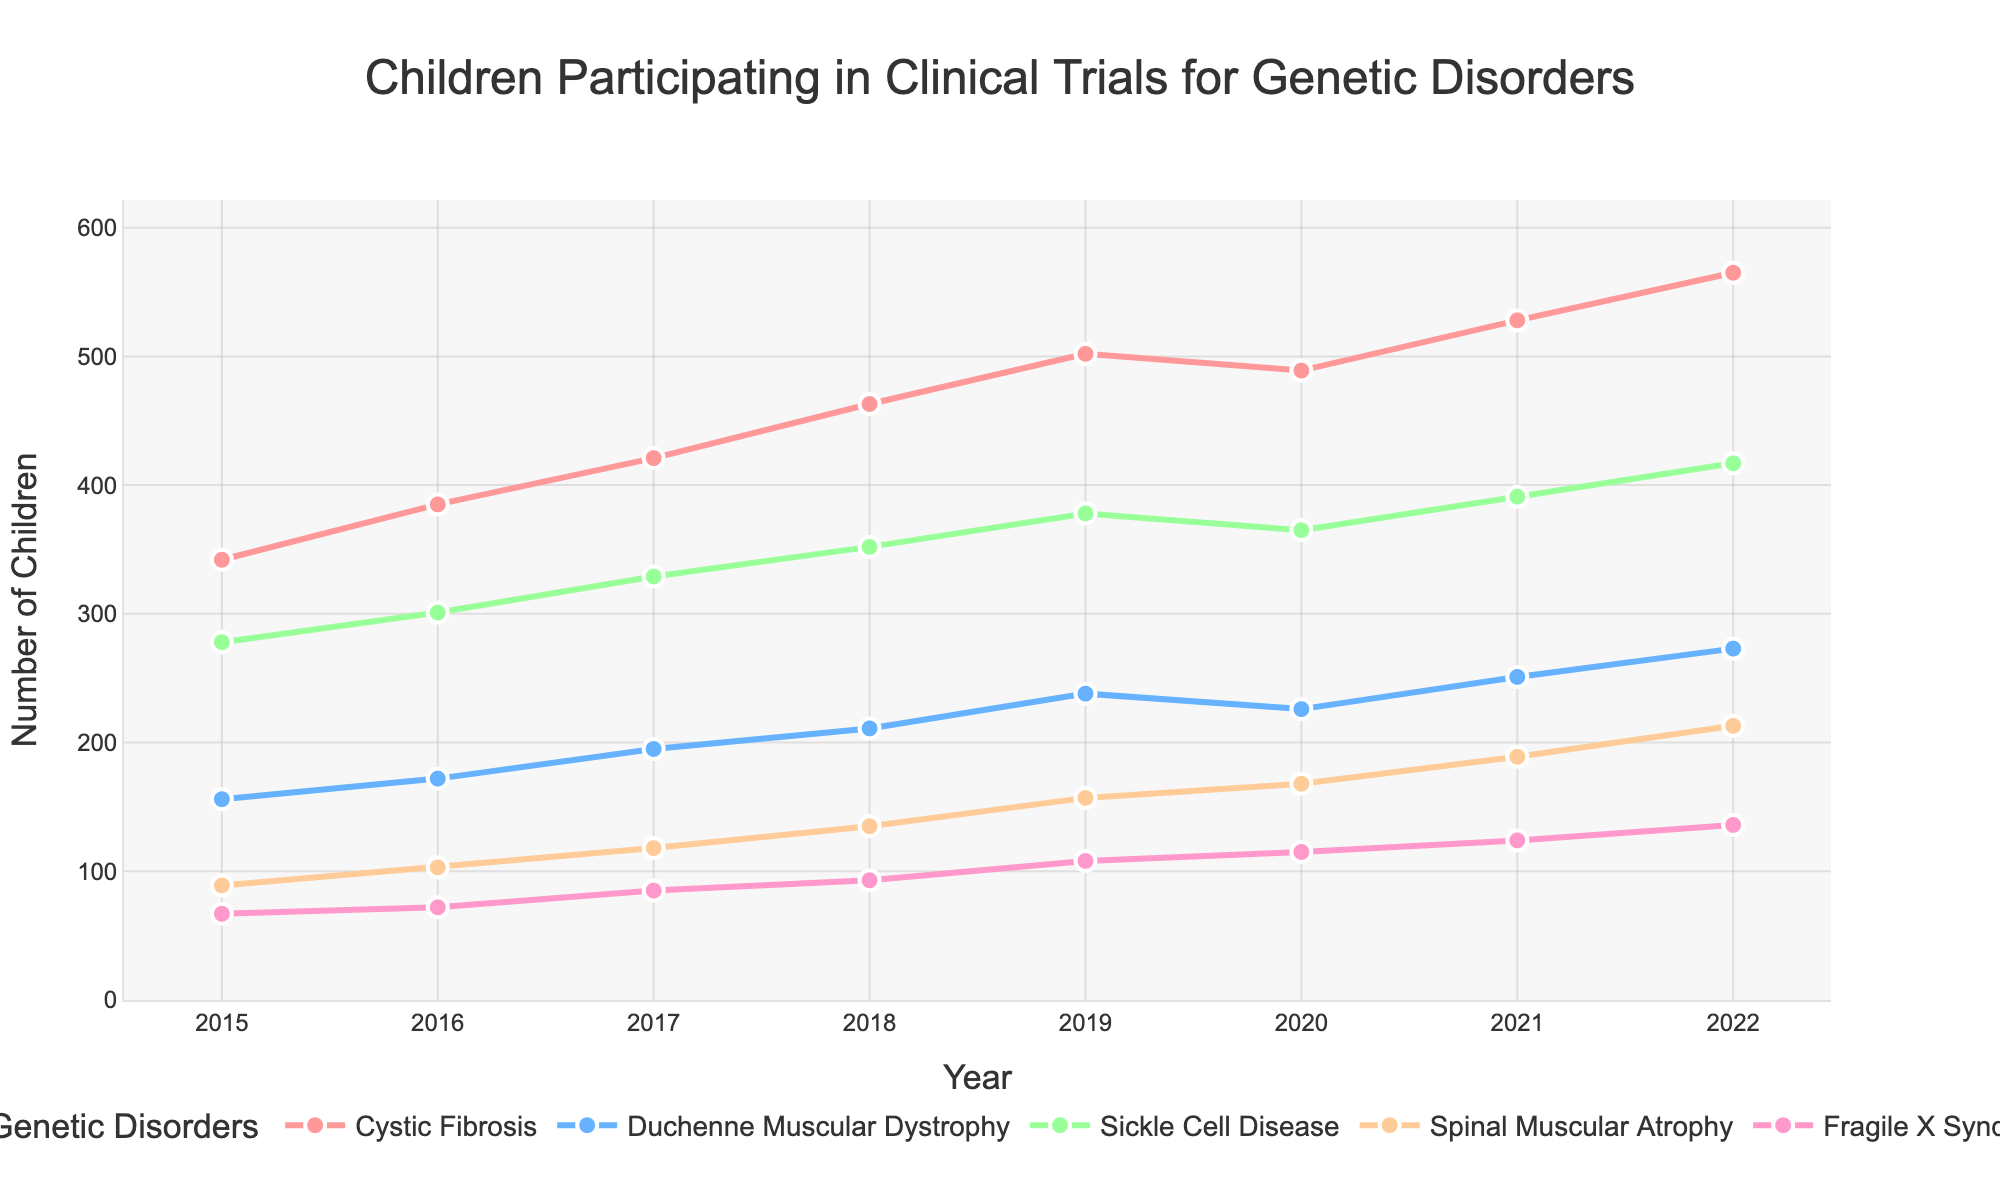Which genetic disorder had the highest number of children participating in clinical trials in 2022? Look at the highest point of each line in 2022. The highest value in 2022 is for Cystic Fibrosis.
Answer: Cystic Fibrosis Which year had the highest number of children participating in clinical trials for Sickle Cell Disease? Check the Sickle Cell Disease line and identify the year with the highest point. The highest point on the line is in 2022.
Answer: 2022 How did the number of children participating in Duchenne Muscular Dystrophy trials change from 2015 to 2022? Look at the figures in 2015 and 2022 for Duchenne Muscular Dystrophy. Subtract the 2015 value from the 2022 value. The participation increased from 156 to 273.
Answer: Increased Which condition shows a decrease in the number of participants from 2019 to 2020? Compare data points in 2019 and 2020 for all lines. Cystic Fibrosis shows a decrease from 502 in 2019 to 489 in 2020.
Answer: Cystic Fibrosis What is the average number of children participating in clinical trials for Spinal Muscular Atrophy from 2015 to 2022? Sum the values for Spinal Muscular Atrophy from 2015 to 2022, then divide by the number of years. (89+103+118+135+157+168+189+213) / 8 = 147.75.
Answer: 147.75 Between which years did Fragile X Syndrome see the largest increase in participants? Check the Fragile X Syndrome line, and find the year-to-year differences. The largest increase is from 2015 to 2016 (67 to 72).
Answer: 2015 to 2016 Which disorder had the smallest number of children participating in trials in 2015? Look at the 2015 data points for each line and find the smallest value. Fragile X Syndrome had the smallest number with 67 participants.
Answer: Fragile X Syndrome How many more children participated in Cystic Fibrosis trials in 2021 compared to 2018? Subtract the 2018 value from the 2021 value for Cystic Fibrosis. 528 - 463 = 65.
Answer: 65 Which disorder had the closest number of participants in 2020 and 2021? Check the differences between 2020 and 2021 values for each disorder. Duchenne Muscular Dystrophy had 226 in 2020 and 251 in 2021, a relatively smaller change.
Answer: Duchenne Muscular Dystrophy What is the total number of children participating in clinical trials across all conditions in 2019? Sum the 2019 values for all conditions. 502 + 238 + 378 + 157 + 108 = 1383.
Answer: 1383 